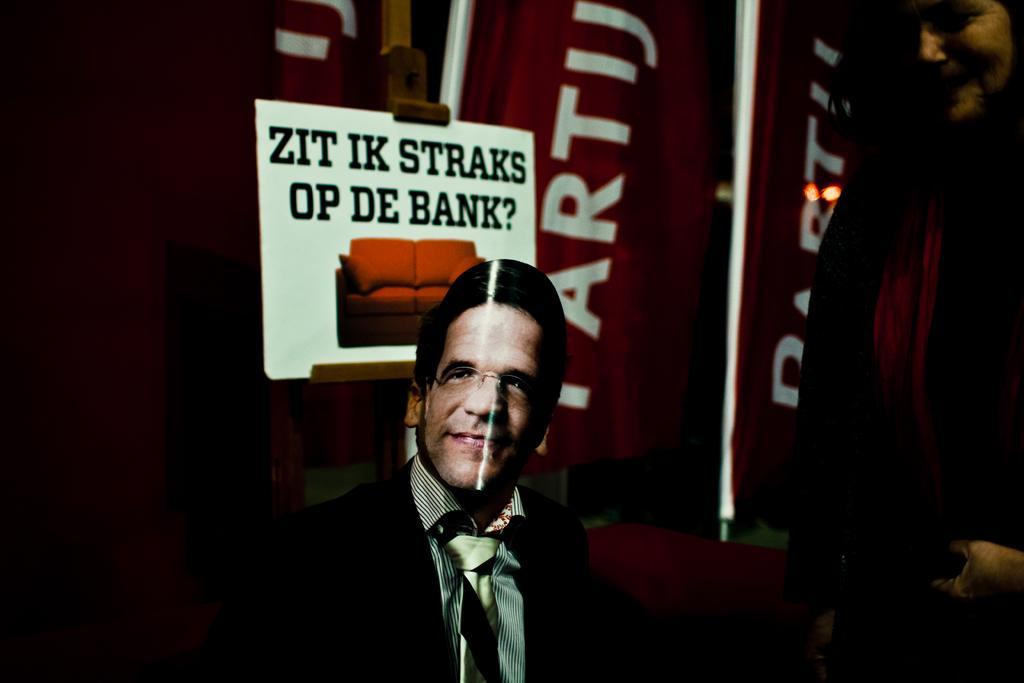In one or two sentences, can you explain what this image depicts? In this image I can see at the bottom it looks like a person wearing the mask. In the middle there is a poster, in the background there are flags and lights. On the right side there is a person. 